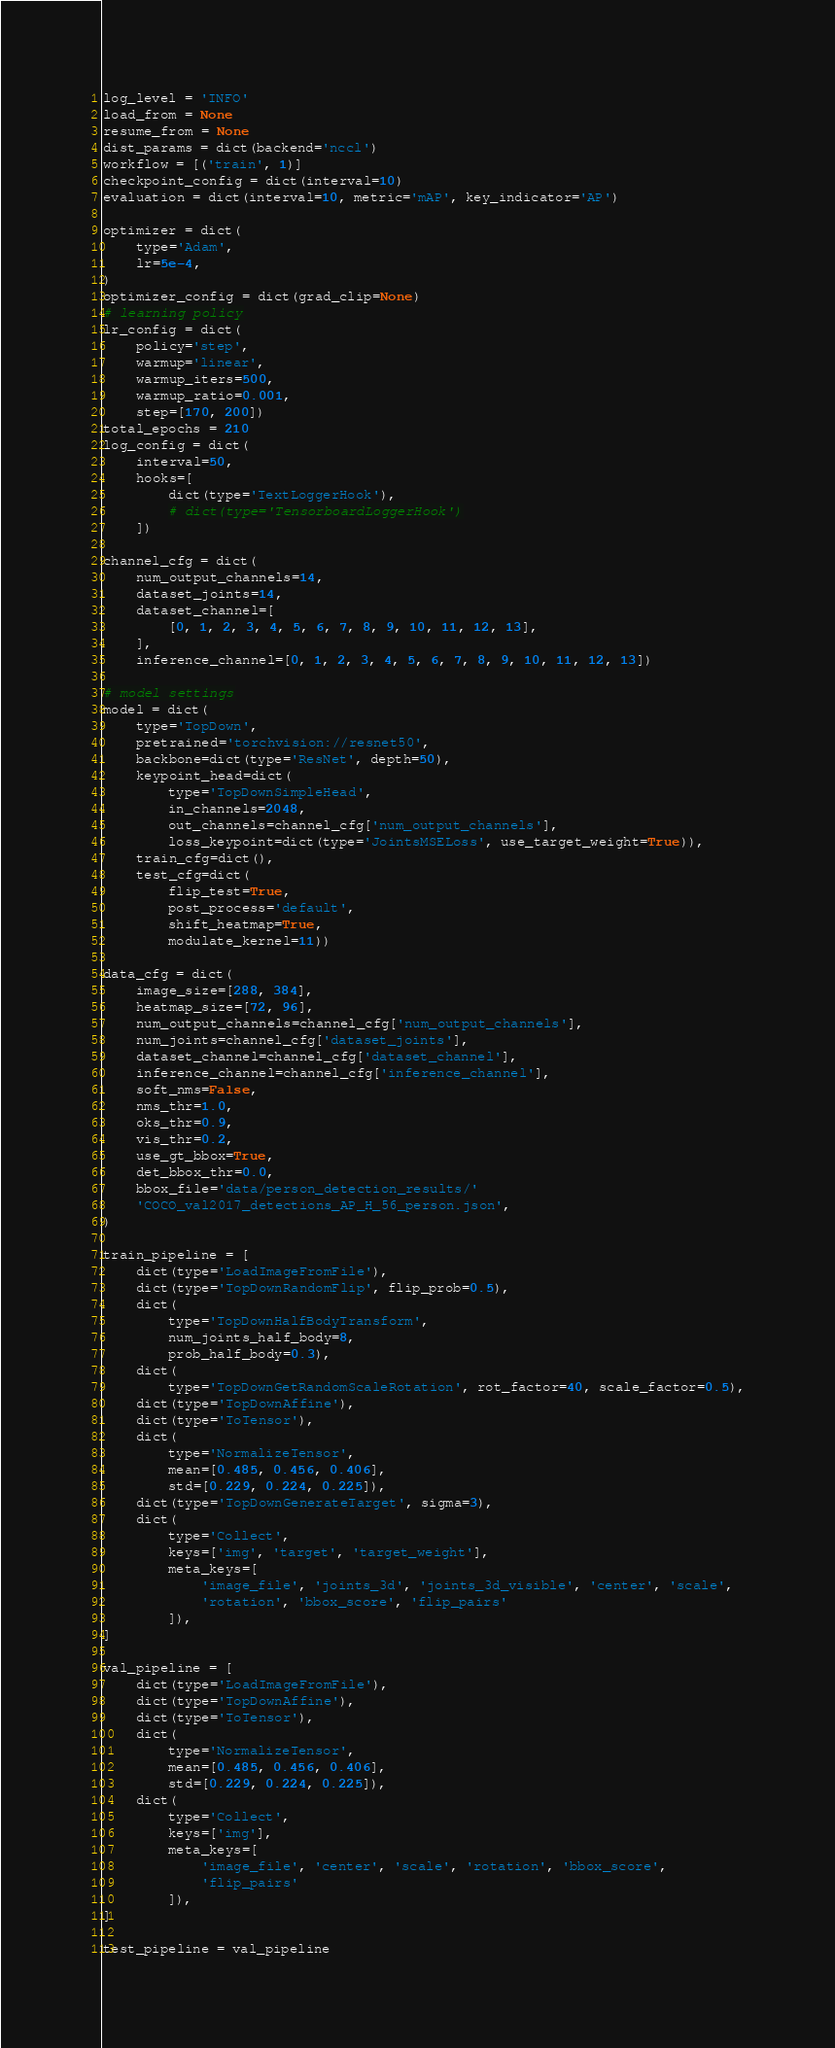Convert code to text. <code><loc_0><loc_0><loc_500><loc_500><_Python_>log_level = 'INFO'
load_from = None
resume_from = None
dist_params = dict(backend='nccl')
workflow = [('train', 1)]
checkpoint_config = dict(interval=10)
evaluation = dict(interval=10, metric='mAP', key_indicator='AP')

optimizer = dict(
    type='Adam',
    lr=5e-4,
)
optimizer_config = dict(grad_clip=None)
# learning policy
lr_config = dict(
    policy='step',
    warmup='linear',
    warmup_iters=500,
    warmup_ratio=0.001,
    step=[170, 200])
total_epochs = 210
log_config = dict(
    interval=50,
    hooks=[
        dict(type='TextLoggerHook'),
        # dict(type='TensorboardLoggerHook')
    ])

channel_cfg = dict(
    num_output_channels=14,
    dataset_joints=14,
    dataset_channel=[
        [0, 1, 2, 3, 4, 5, 6, 7, 8, 9, 10, 11, 12, 13],
    ],
    inference_channel=[0, 1, 2, 3, 4, 5, 6, 7, 8, 9, 10, 11, 12, 13])

# model settings
model = dict(
    type='TopDown',
    pretrained='torchvision://resnet50',
    backbone=dict(type='ResNet', depth=50),
    keypoint_head=dict(
        type='TopDownSimpleHead',
        in_channels=2048,
        out_channels=channel_cfg['num_output_channels'],
        loss_keypoint=dict(type='JointsMSELoss', use_target_weight=True)),
    train_cfg=dict(),
    test_cfg=dict(
        flip_test=True,
        post_process='default',
        shift_heatmap=True,
        modulate_kernel=11))

data_cfg = dict(
    image_size=[288, 384],
    heatmap_size=[72, 96],
    num_output_channels=channel_cfg['num_output_channels'],
    num_joints=channel_cfg['dataset_joints'],
    dataset_channel=channel_cfg['dataset_channel'],
    inference_channel=channel_cfg['inference_channel'],
    soft_nms=False,
    nms_thr=1.0,
    oks_thr=0.9,
    vis_thr=0.2,
    use_gt_bbox=True,
    det_bbox_thr=0.0,
    bbox_file='data/person_detection_results/'
    'COCO_val2017_detections_AP_H_56_person.json',
)

train_pipeline = [
    dict(type='LoadImageFromFile'),
    dict(type='TopDownRandomFlip', flip_prob=0.5),
    dict(
        type='TopDownHalfBodyTransform',
        num_joints_half_body=8,
        prob_half_body=0.3),
    dict(
        type='TopDownGetRandomScaleRotation', rot_factor=40, scale_factor=0.5),
    dict(type='TopDownAffine'),
    dict(type='ToTensor'),
    dict(
        type='NormalizeTensor',
        mean=[0.485, 0.456, 0.406],
        std=[0.229, 0.224, 0.225]),
    dict(type='TopDownGenerateTarget', sigma=3),
    dict(
        type='Collect',
        keys=['img', 'target', 'target_weight'],
        meta_keys=[
            'image_file', 'joints_3d', 'joints_3d_visible', 'center', 'scale',
            'rotation', 'bbox_score', 'flip_pairs'
        ]),
]

val_pipeline = [
    dict(type='LoadImageFromFile'),
    dict(type='TopDownAffine'),
    dict(type='ToTensor'),
    dict(
        type='NormalizeTensor',
        mean=[0.485, 0.456, 0.406],
        std=[0.229, 0.224, 0.225]),
    dict(
        type='Collect',
        keys=['img'],
        meta_keys=[
            'image_file', 'center', 'scale', 'rotation', 'bbox_score',
            'flip_pairs'
        ]),
]

test_pipeline = val_pipeline
</code> 